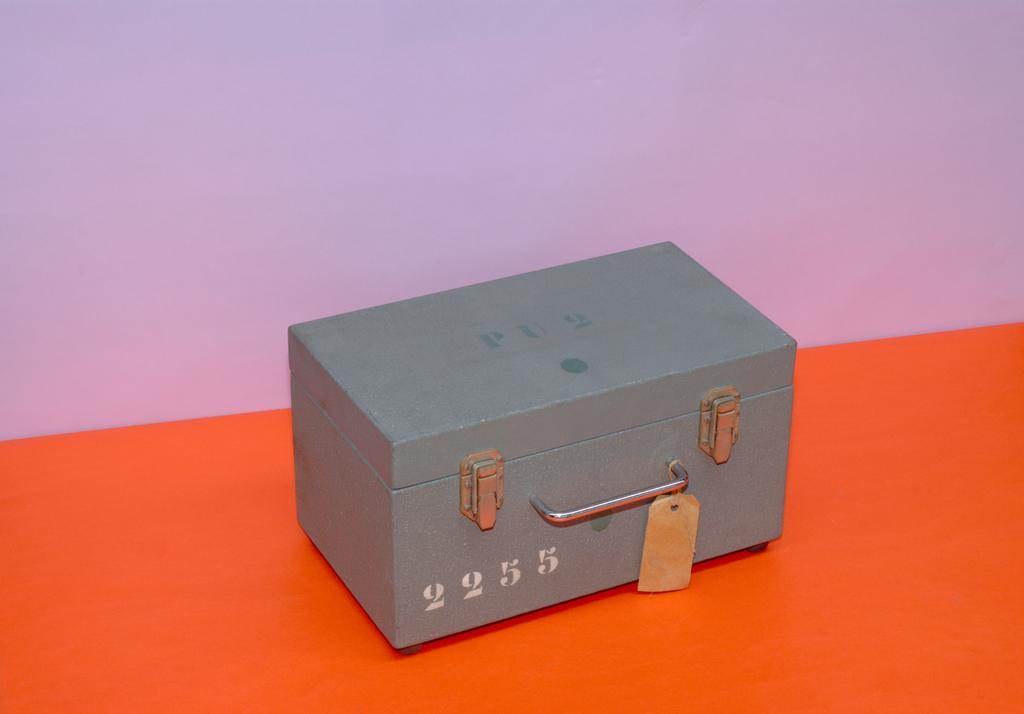<image>
Describe the image concisely. Grey box with white numbers on it that say 2255. 